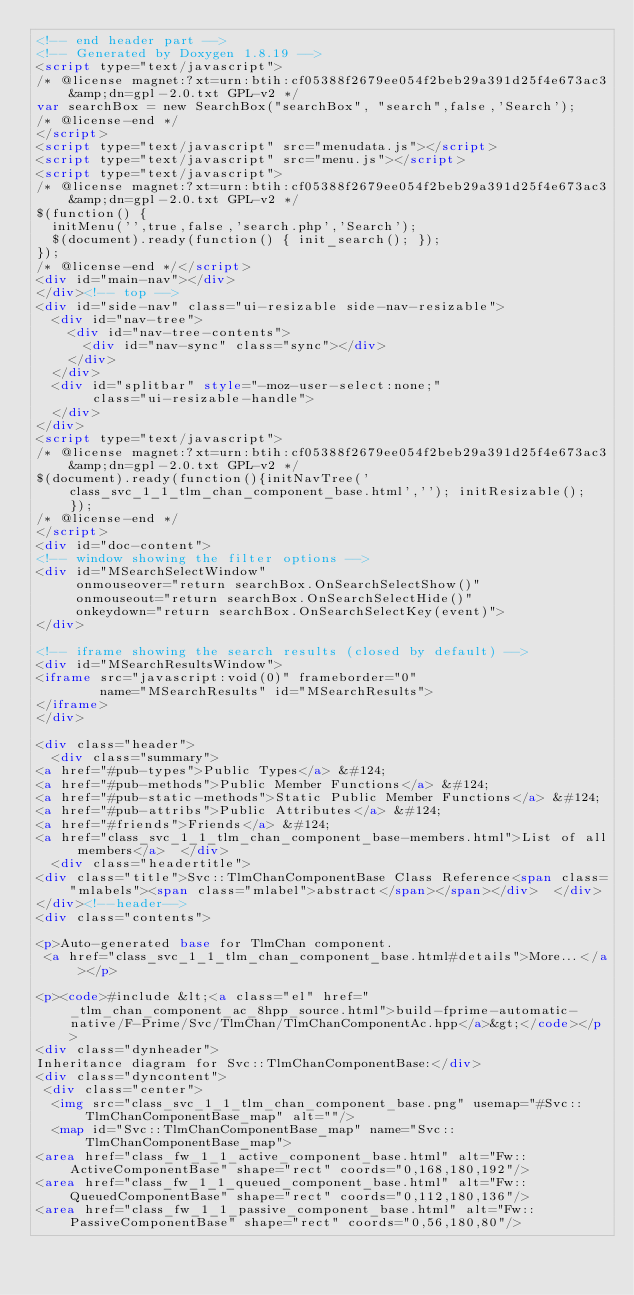Convert code to text. <code><loc_0><loc_0><loc_500><loc_500><_HTML_><!-- end header part -->
<!-- Generated by Doxygen 1.8.19 -->
<script type="text/javascript">
/* @license magnet:?xt=urn:btih:cf05388f2679ee054f2beb29a391d25f4e673ac3&amp;dn=gpl-2.0.txt GPL-v2 */
var searchBox = new SearchBox("searchBox", "search",false,'Search');
/* @license-end */
</script>
<script type="text/javascript" src="menudata.js"></script>
<script type="text/javascript" src="menu.js"></script>
<script type="text/javascript">
/* @license magnet:?xt=urn:btih:cf05388f2679ee054f2beb29a391d25f4e673ac3&amp;dn=gpl-2.0.txt GPL-v2 */
$(function() {
  initMenu('',true,false,'search.php','Search');
  $(document).ready(function() { init_search(); });
});
/* @license-end */</script>
<div id="main-nav"></div>
</div><!-- top -->
<div id="side-nav" class="ui-resizable side-nav-resizable">
  <div id="nav-tree">
    <div id="nav-tree-contents">
      <div id="nav-sync" class="sync"></div>
    </div>
  </div>
  <div id="splitbar" style="-moz-user-select:none;" 
       class="ui-resizable-handle">
  </div>
</div>
<script type="text/javascript">
/* @license magnet:?xt=urn:btih:cf05388f2679ee054f2beb29a391d25f4e673ac3&amp;dn=gpl-2.0.txt GPL-v2 */
$(document).ready(function(){initNavTree('class_svc_1_1_tlm_chan_component_base.html',''); initResizable(); });
/* @license-end */
</script>
<div id="doc-content">
<!-- window showing the filter options -->
<div id="MSearchSelectWindow"
     onmouseover="return searchBox.OnSearchSelectShow()"
     onmouseout="return searchBox.OnSearchSelectHide()"
     onkeydown="return searchBox.OnSearchSelectKey(event)">
</div>

<!-- iframe showing the search results (closed by default) -->
<div id="MSearchResultsWindow">
<iframe src="javascript:void(0)" frameborder="0" 
        name="MSearchResults" id="MSearchResults">
</iframe>
</div>

<div class="header">
  <div class="summary">
<a href="#pub-types">Public Types</a> &#124;
<a href="#pub-methods">Public Member Functions</a> &#124;
<a href="#pub-static-methods">Static Public Member Functions</a> &#124;
<a href="#pub-attribs">Public Attributes</a> &#124;
<a href="#friends">Friends</a> &#124;
<a href="class_svc_1_1_tlm_chan_component_base-members.html">List of all members</a>  </div>
  <div class="headertitle">
<div class="title">Svc::TlmChanComponentBase Class Reference<span class="mlabels"><span class="mlabel">abstract</span></span></div>  </div>
</div><!--header-->
<div class="contents">

<p>Auto-generated base for TlmChan component.  
 <a href="class_svc_1_1_tlm_chan_component_base.html#details">More...</a></p>

<p><code>#include &lt;<a class="el" href="_tlm_chan_component_ac_8hpp_source.html">build-fprime-automatic-native/F-Prime/Svc/TlmChan/TlmChanComponentAc.hpp</a>&gt;</code></p>
<div class="dynheader">
Inheritance diagram for Svc::TlmChanComponentBase:</div>
<div class="dyncontent">
 <div class="center">
  <img src="class_svc_1_1_tlm_chan_component_base.png" usemap="#Svc::TlmChanComponentBase_map" alt=""/>
  <map id="Svc::TlmChanComponentBase_map" name="Svc::TlmChanComponentBase_map">
<area href="class_fw_1_1_active_component_base.html" alt="Fw::ActiveComponentBase" shape="rect" coords="0,168,180,192"/>
<area href="class_fw_1_1_queued_component_base.html" alt="Fw::QueuedComponentBase" shape="rect" coords="0,112,180,136"/>
<area href="class_fw_1_1_passive_component_base.html" alt="Fw::PassiveComponentBase" shape="rect" coords="0,56,180,80"/></code> 